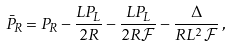Convert formula to latex. <formula><loc_0><loc_0><loc_500><loc_500>\bar { P } _ { R } = P _ { R } - \frac { L P _ { L } } { 2 R } - \frac { L P _ { L } } { 2 R \mathcal { F } } - \frac { \Delta } { R L ^ { 2 } \mathcal { F } } \, ,</formula> 